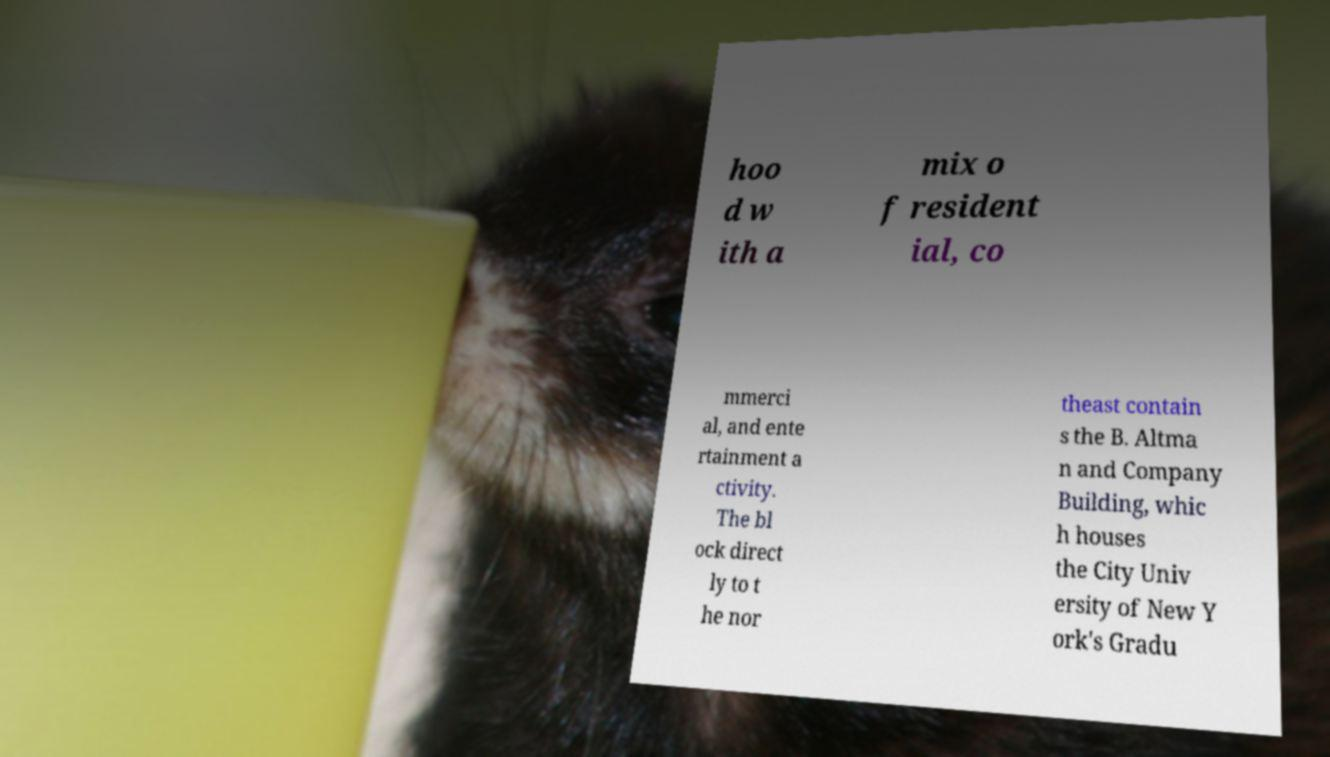Please identify and transcribe the text found in this image. hoo d w ith a mix o f resident ial, co mmerci al, and ente rtainment a ctivity. The bl ock direct ly to t he nor theast contain s the B. Altma n and Company Building, whic h houses the City Univ ersity of New Y ork's Gradu 